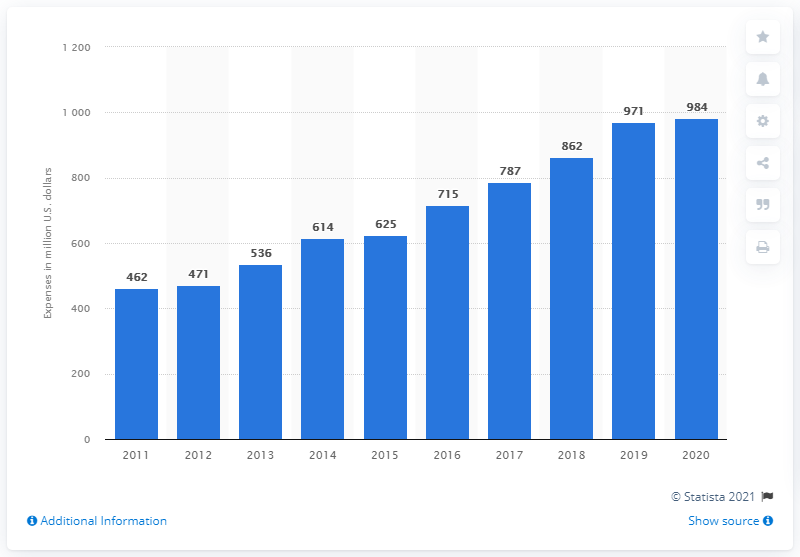What might be the reason for the sharp increase in R&D spending from 2019 to 2020? The sharp increase in research and development spending from 971 million U.S. dollars in 2019 to 984 million in 2020 might be attributed to a strategic decision to pursue new product development, a response to evolving market demands, or an increased focus on technological innovation. Additionally, changes in health care regulations or the emergence of new medical challenges, such as the COVID-19 pandemic, could have necessitated further investment. 